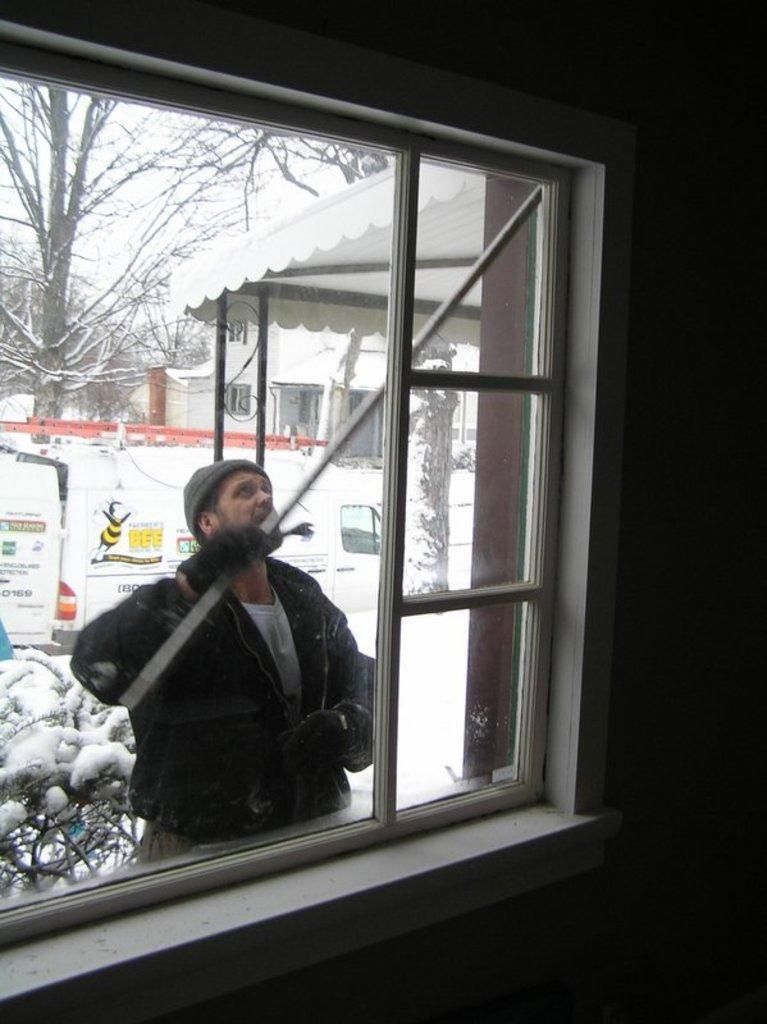Could you give a brief overview of what you see in this image? In the middle a man is standing ,he wore a coat and this is the window, there is a tree in the left side of an image. 